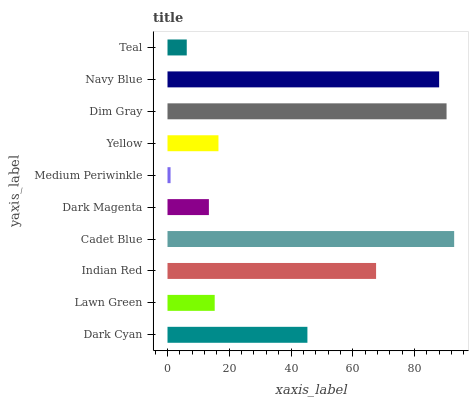Is Medium Periwinkle the minimum?
Answer yes or no. Yes. Is Cadet Blue the maximum?
Answer yes or no. Yes. Is Lawn Green the minimum?
Answer yes or no. No. Is Lawn Green the maximum?
Answer yes or no. No. Is Dark Cyan greater than Lawn Green?
Answer yes or no. Yes. Is Lawn Green less than Dark Cyan?
Answer yes or no. Yes. Is Lawn Green greater than Dark Cyan?
Answer yes or no. No. Is Dark Cyan less than Lawn Green?
Answer yes or no. No. Is Dark Cyan the high median?
Answer yes or no. Yes. Is Yellow the low median?
Answer yes or no. Yes. Is Indian Red the high median?
Answer yes or no. No. Is Indian Red the low median?
Answer yes or no. No. 